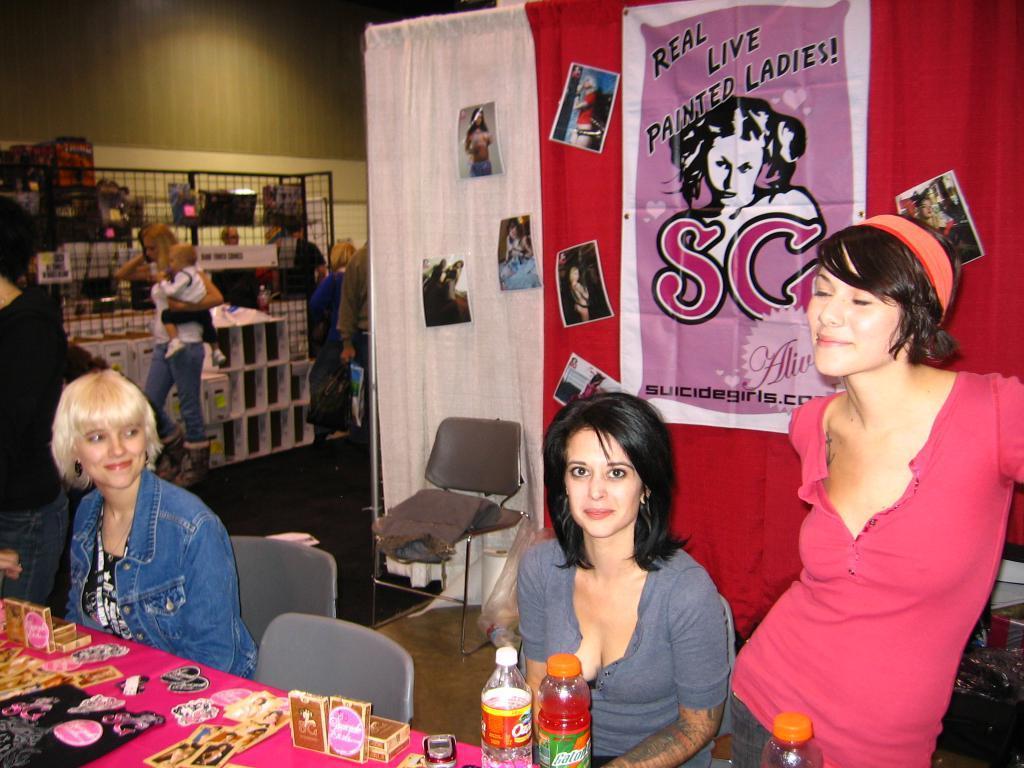Describe this image in one or two sentences. In this picture we have 2 persons sitting in the chair another person standing near the table and in table we have papers, labels ,box, bottles and in the back ground we have chair , banner, curtain ,another person standing and racks. 